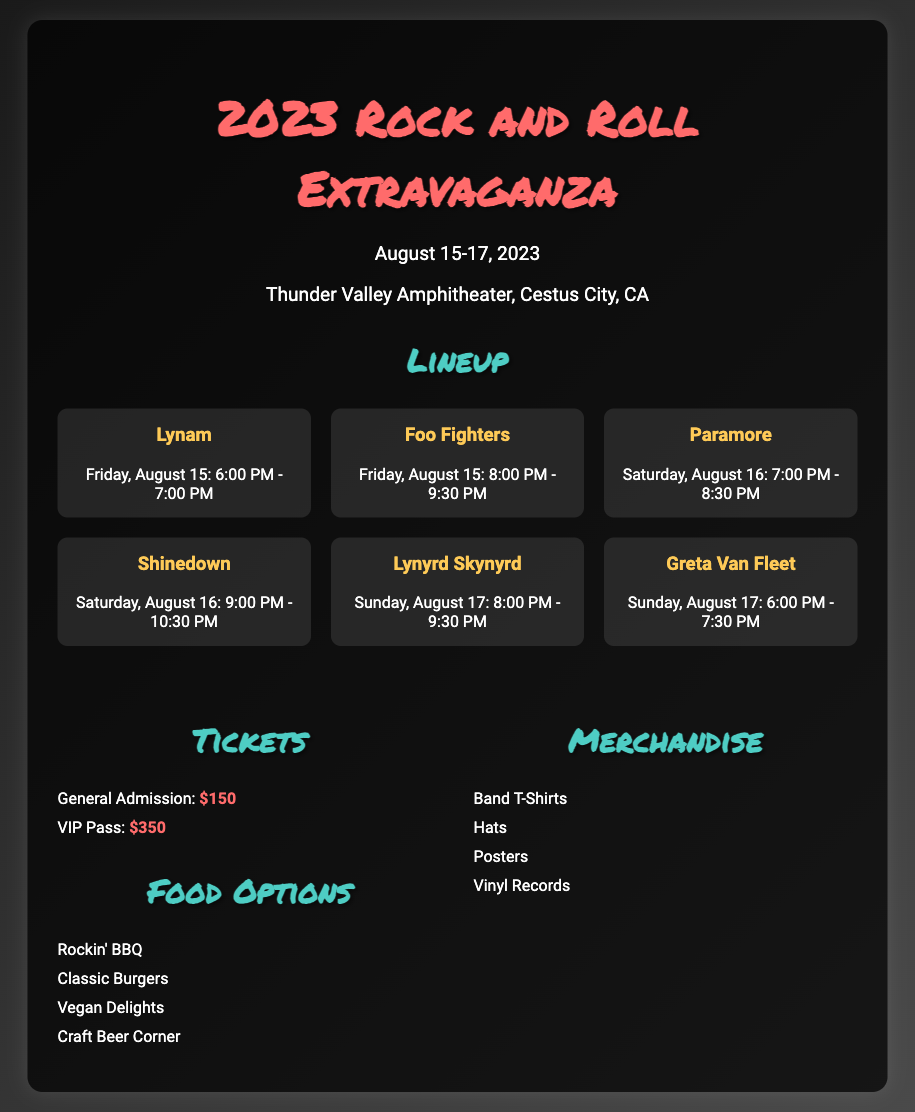What is the venue for the festival? The venue mentioned in the document is Thunder Valley Amphitheater, Cestus City, CA.
Answer: Thunder Valley Amphitheater, Cestus City, CA When does Lynam perform? Lynam's performance time is specifically listed as Friday, August 15 from 6:00 PM to 7:00 PM.
Answer: Friday, August 15: 6:00 PM - 7:00 PM How much is a VIP pass? The document clearly states that the price for a VIP pass is $350.
Answer: $350 Which band performs right before Lynyrd Skynyrd? The band that performs before Lynyrd Skynyrd is Greta Van Fleet, scheduled for Sunday from 6:00 PM to 7:30 PM.
Answer: Greta Van Fleet What food options are available? The document lists several food options including Rockin' BBQ, Classic Burgers, and Vegan Delights.
Answer: Rockin' BBQ, Classic Burgers, Vegan Delights How many days does the festival last? The festival is scheduled to take place over three days, from August 15 to August 17.
Answer: Three days What is the set time for Shinedown? Shinedown's set time is provided as Saturday, August 16 from 9:00 PM to 10:30 PM in the lineup.
Answer: Saturday, August 16: 9:00 PM - 10:30 PM What is the color of the headings in the document? The headings have a color styling of #ff6b6b for the main title and #4ecdc4 for subheadings, as outlined in the CSS.
Answer: #ff6b6b, #4ecdc4 